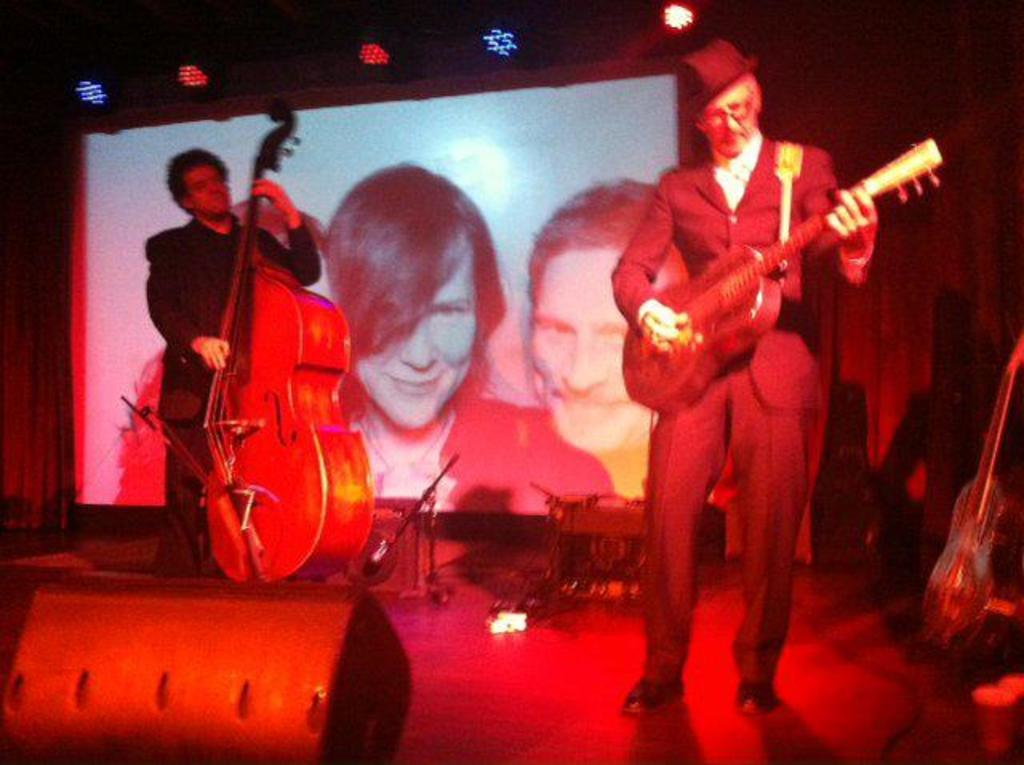What is the man in the image doing? The man is playing a violin and a guitar in the image. Can you describe the musical instruments the man is playing? The man is playing a violin and a guitar in the image. What can be seen in the background of the image? There is a screen in the background of the image. What type of hat is the man wearing in the image? There is no hat visible in the image; the man is only shown playing a violin and a guitar. 